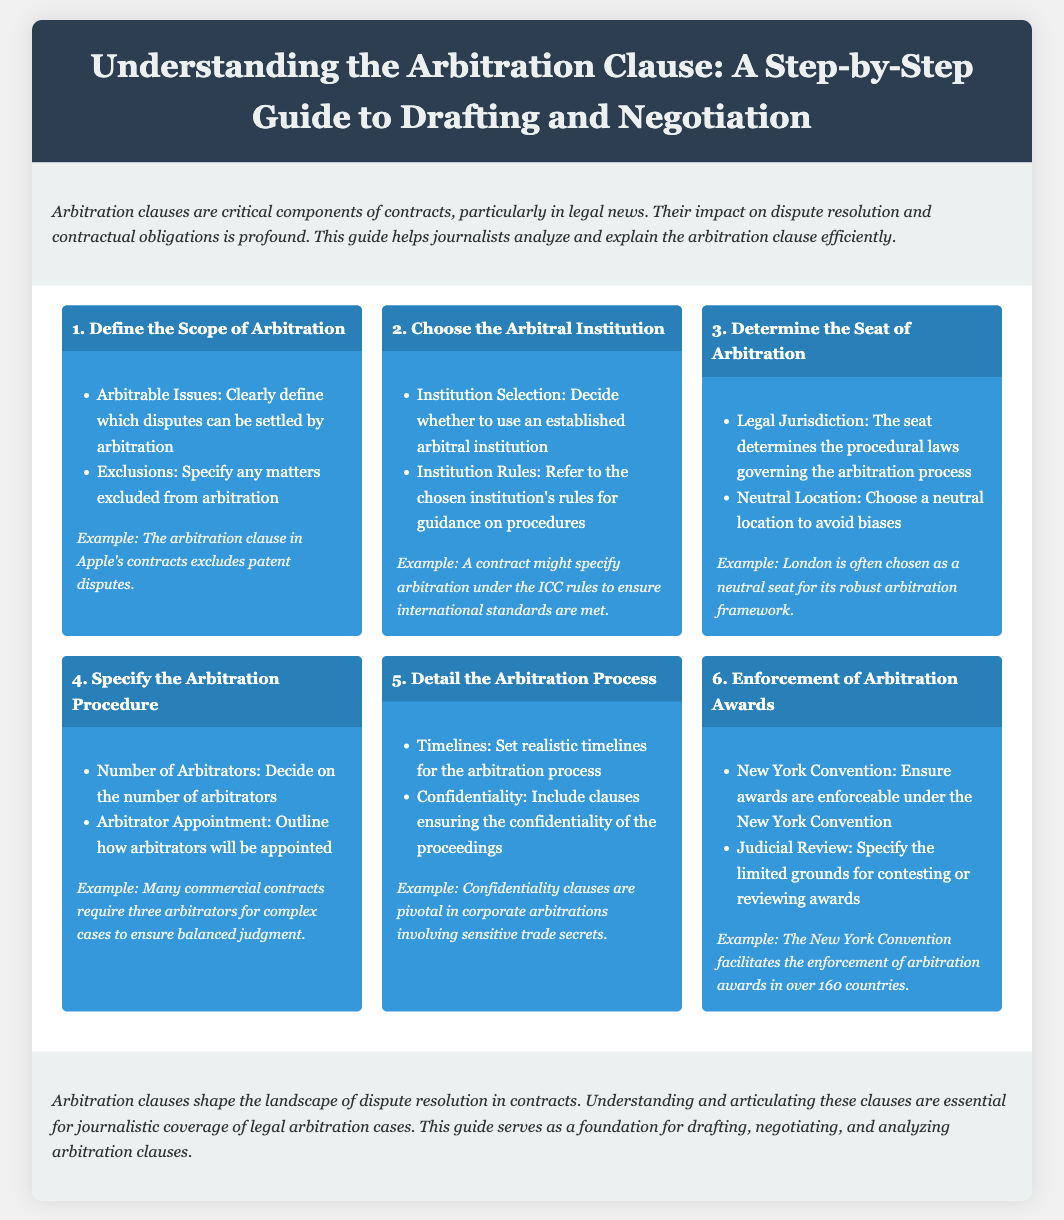what is the title of the document? The title is prominently displayed in the header section of the document, stating the focus on arbitration clauses.
Answer: Understanding the Arbitration Clause: A Step-by-Step Guide to Drafting and Negotiation how many main steps are detailed in the process? The document outlines a total of six distinct steps involved in understanding arbitration clauses.
Answer: 6 what is the example given for specifying the arbitration procedure? The example illustrates the common practice in commercial contracts regarding the appointment of arbitrators.
Answer: Many commercial contracts require three arbitrators for complex cases to ensure balanced judgment which arbitration award enforcement convention is mentioned? The document specifies which international convention governs the enforceability of arbitration awards.
Answer: New York Convention what is suggested as a neutral location for determining the seat of arbitration? The document provides an example of a location that is often selected for its neutrality in arbitral proceedings.
Answer: London what are the two aspects indicated in the 'Detail the Arbitration Process' step? This step highlights key elements that need to be addressed regarding the arbitration timeline and its confidentiality.
Answer: Timelines and Confidentiality 